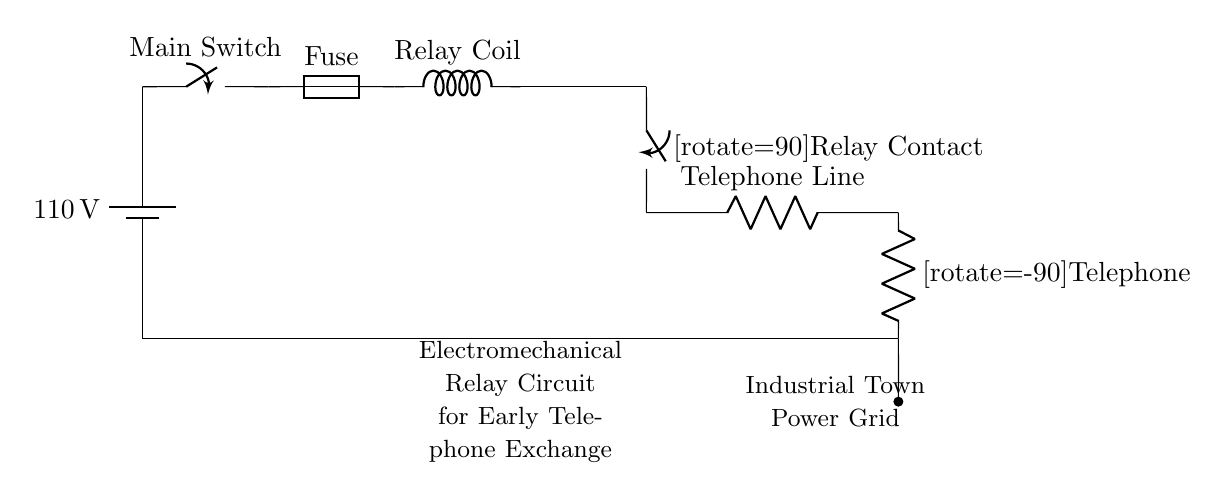What is the main voltage in this circuit? The main voltage is indicated next to the battery symbol in the circuit diagram, which shows a potential difference of 110 volts.
Answer: 110 volts What component is responsible for switching the circuit? The main switch is specified in the diagram, which is located near the power source and allows control over the flow of electricity in the circuit.
Answer: Main Switch How does the relay coil function in this circuit? The relay coil receives an electrical signal when current flows through it, which activates the relay and connects the telephone line to the power source, allowing communication.
Answer: Activates the relay What protects this circuit from overcurrent? The fuse is included in the circuit diagram and is designed to break the circuit if the current exceeds safe levels, protecting the components from damage.
Answer: Fuse What is the purpose of the telephone line in this setup? The telephone line connects the relay contact to the telephone, allowing for the transmission of electrical signals that correspond to voice communication.
Answer: Transmission of voice signals How many components directly connect to the relay coil? There are two components: the fuse and the relay contact, which are directly connected to the relay coil, facilitating its operation within the circuit.
Answer: Two components What is the load in this electromechanical relay circuit? The load in this circuit is the telephone, which draws current when used, enabling communication through the system.
Answer: Telephone 